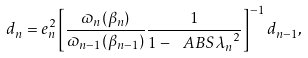<formula> <loc_0><loc_0><loc_500><loc_500>d _ { n } = e _ { n } ^ { 2 } \left [ \frac { \varpi _ { n } ( \beta _ { n } ) } { \varpi _ { n - 1 } ( \beta _ { n - 1 } ) } \frac { 1 } { 1 - \ A B S { \lambda _ { n } } ^ { 2 } } \right ] ^ { - 1 } d _ { n - 1 } ,</formula> 